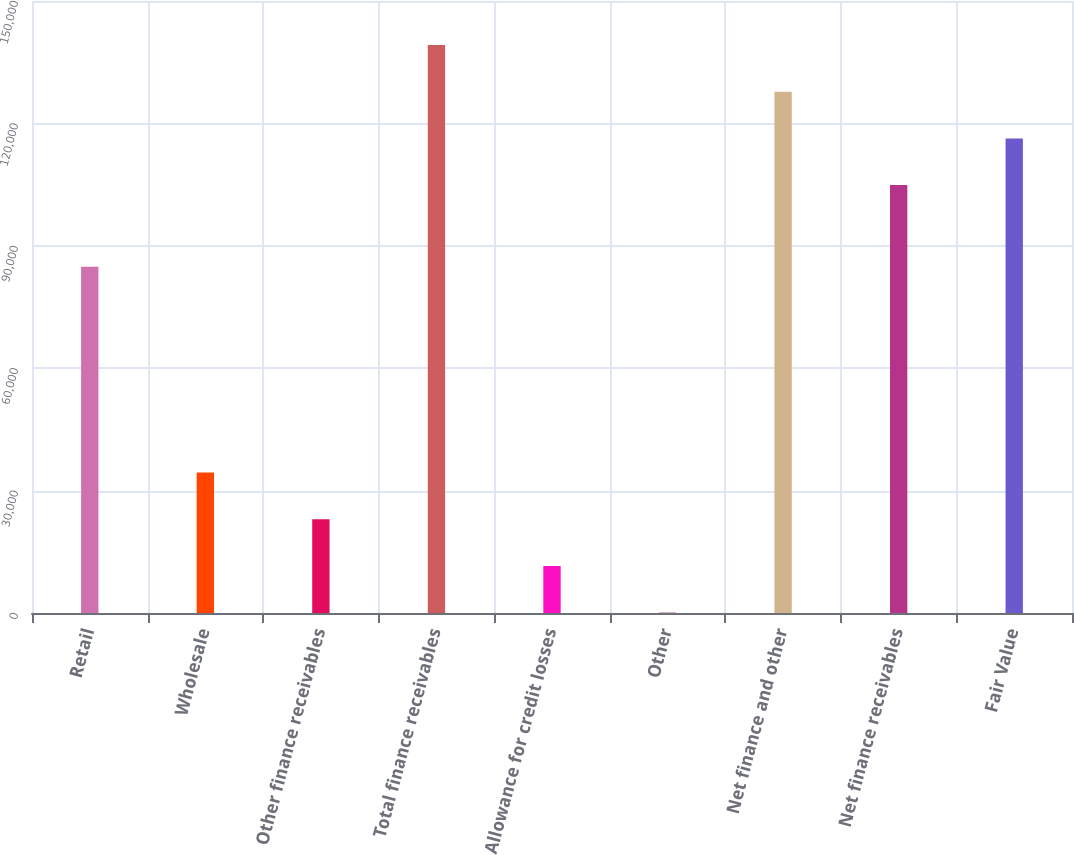<chart> <loc_0><loc_0><loc_500><loc_500><bar_chart><fcel>Retail<fcel>Wholesale<fcel>Other finance receivables<fcel>Total finance receivables<fcel>Allowance for credit losses<fcel>Other<fcel>Net finance and other<fcel>Net finance receivables<fcel>Fair Value<nl><fcel>84843<fcel>34431.9<fcel>22978.6<fcel>139234<fcel>11525.3<fcel>72<fcel>127781<fcel>104874<fcel>116327<nl></chart> 